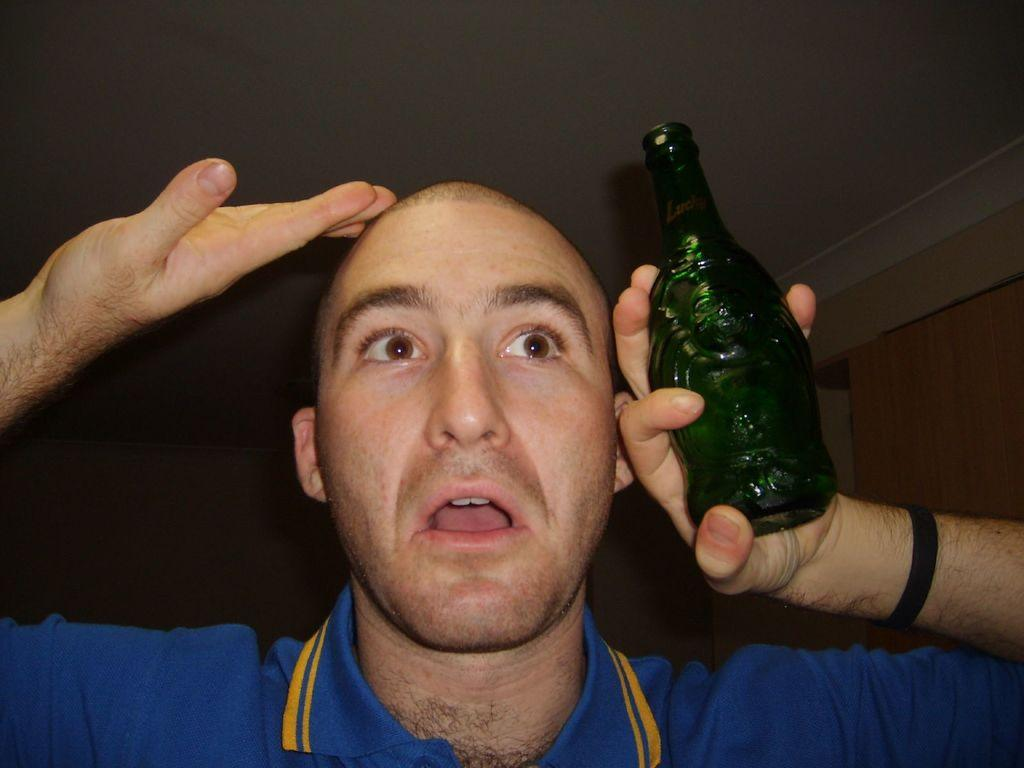What is present in the image? There is a person in the image. What is the person wearing? The person is wearing a blue shirt. What is the person holding? The person is holding a green bottle. What type of quill is the person using to write in the image? There is no quill present in the image; the person is holding a green bottle. Is the queen present in the image? There is no mention of a queen in the image or the provided facts. 